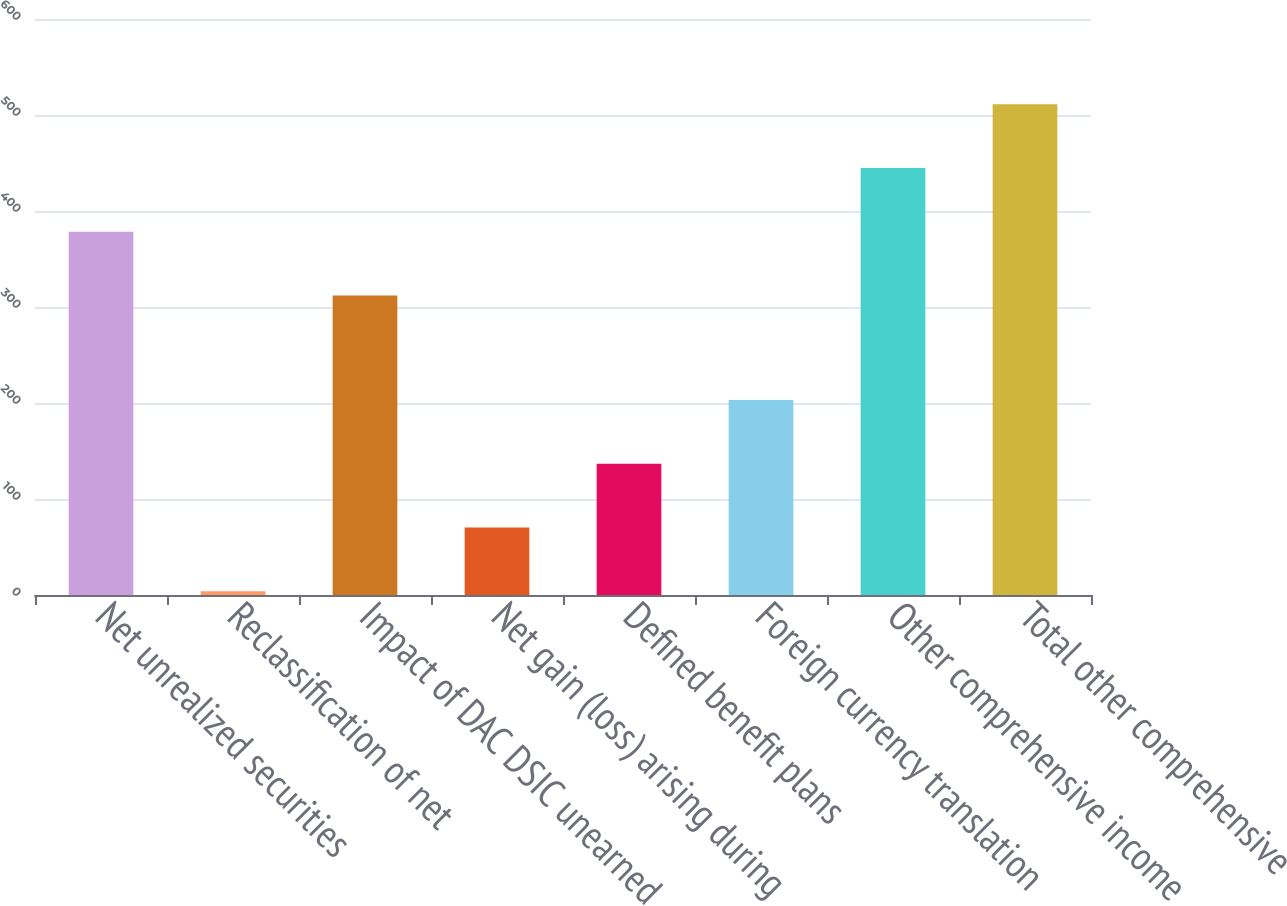Convert chart to OTSL. <chart><loc_0><loc_0><loc_500><loc_500><bar_chart><fcel>Net unrealized securities<fcel>Reclassification of net<fcel>Impact of DAC DSIC unearned<fcel>Net gain (loss) arising during<fcel>Defined benefit plans<fcel>Foreign currency translation<fcel>Other comprehensive income<fcel>Total other comprehensive<nl><fcel>378.4<fcel>4<fcel>312<fcel>70.4<fcel>136.8<fcel>203.2<fcel>444.8<fcel>511.2<nl></chart> 